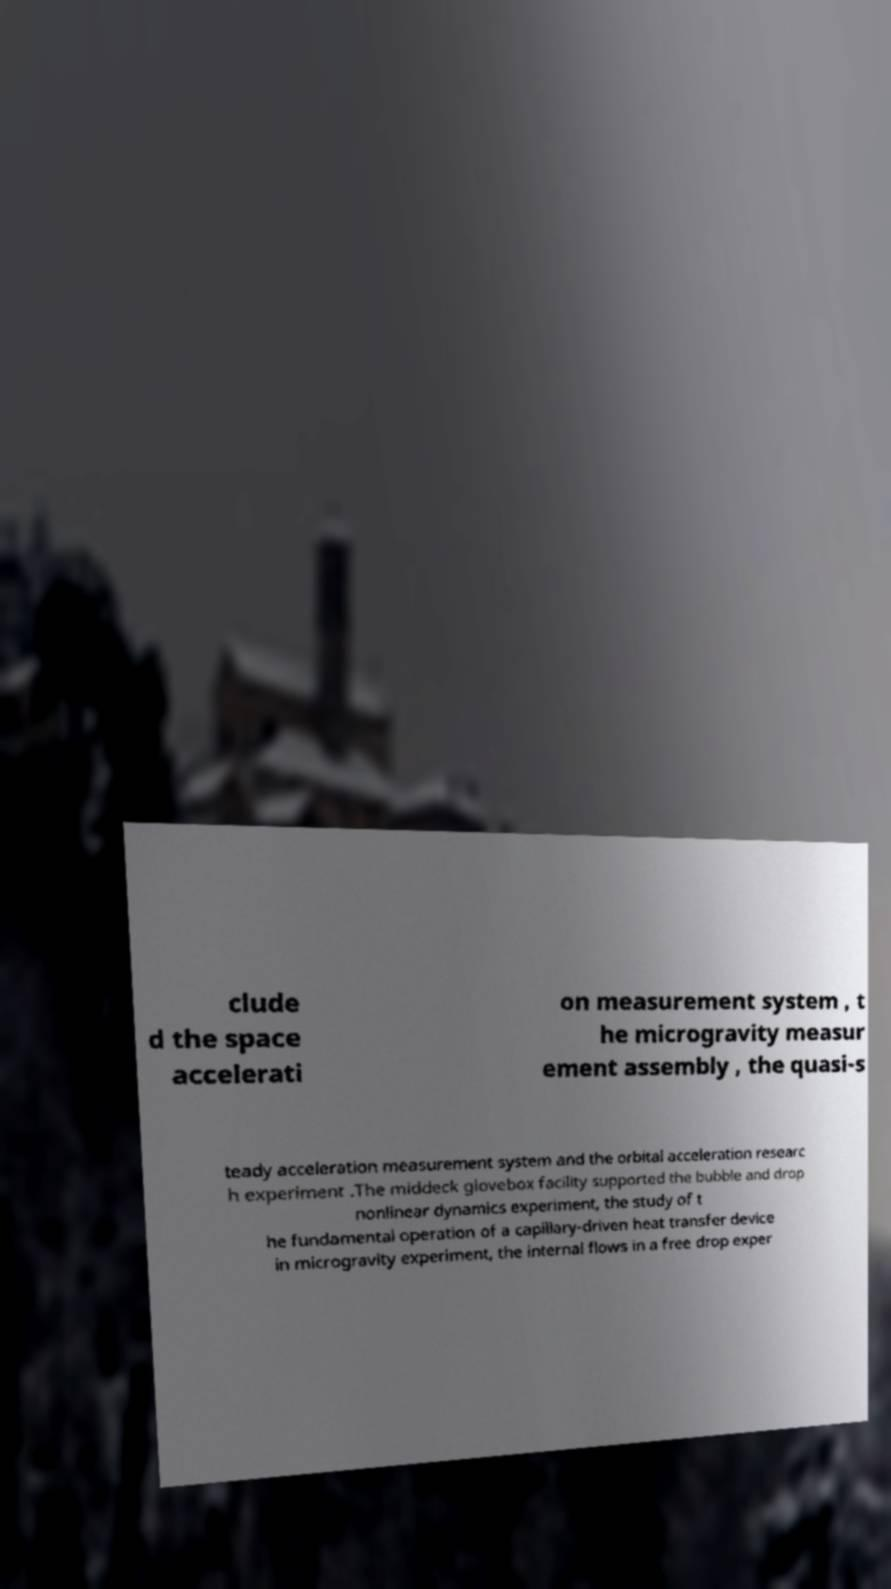Please identify and transcribe the text found in this image. clude d the space accelerati on measurement system , t he microgravity measur ement assembly , the quasi-s teady acceleration measurement system and the orbital acceleration researc h experiment .The middeck glovebox facility supported the bubble and drop nonlinear dynamics experiment, the study of t he fundamental operation of a capillary-driven heat transfer device in microgravity experiment, the internal flows in a free drop exper 